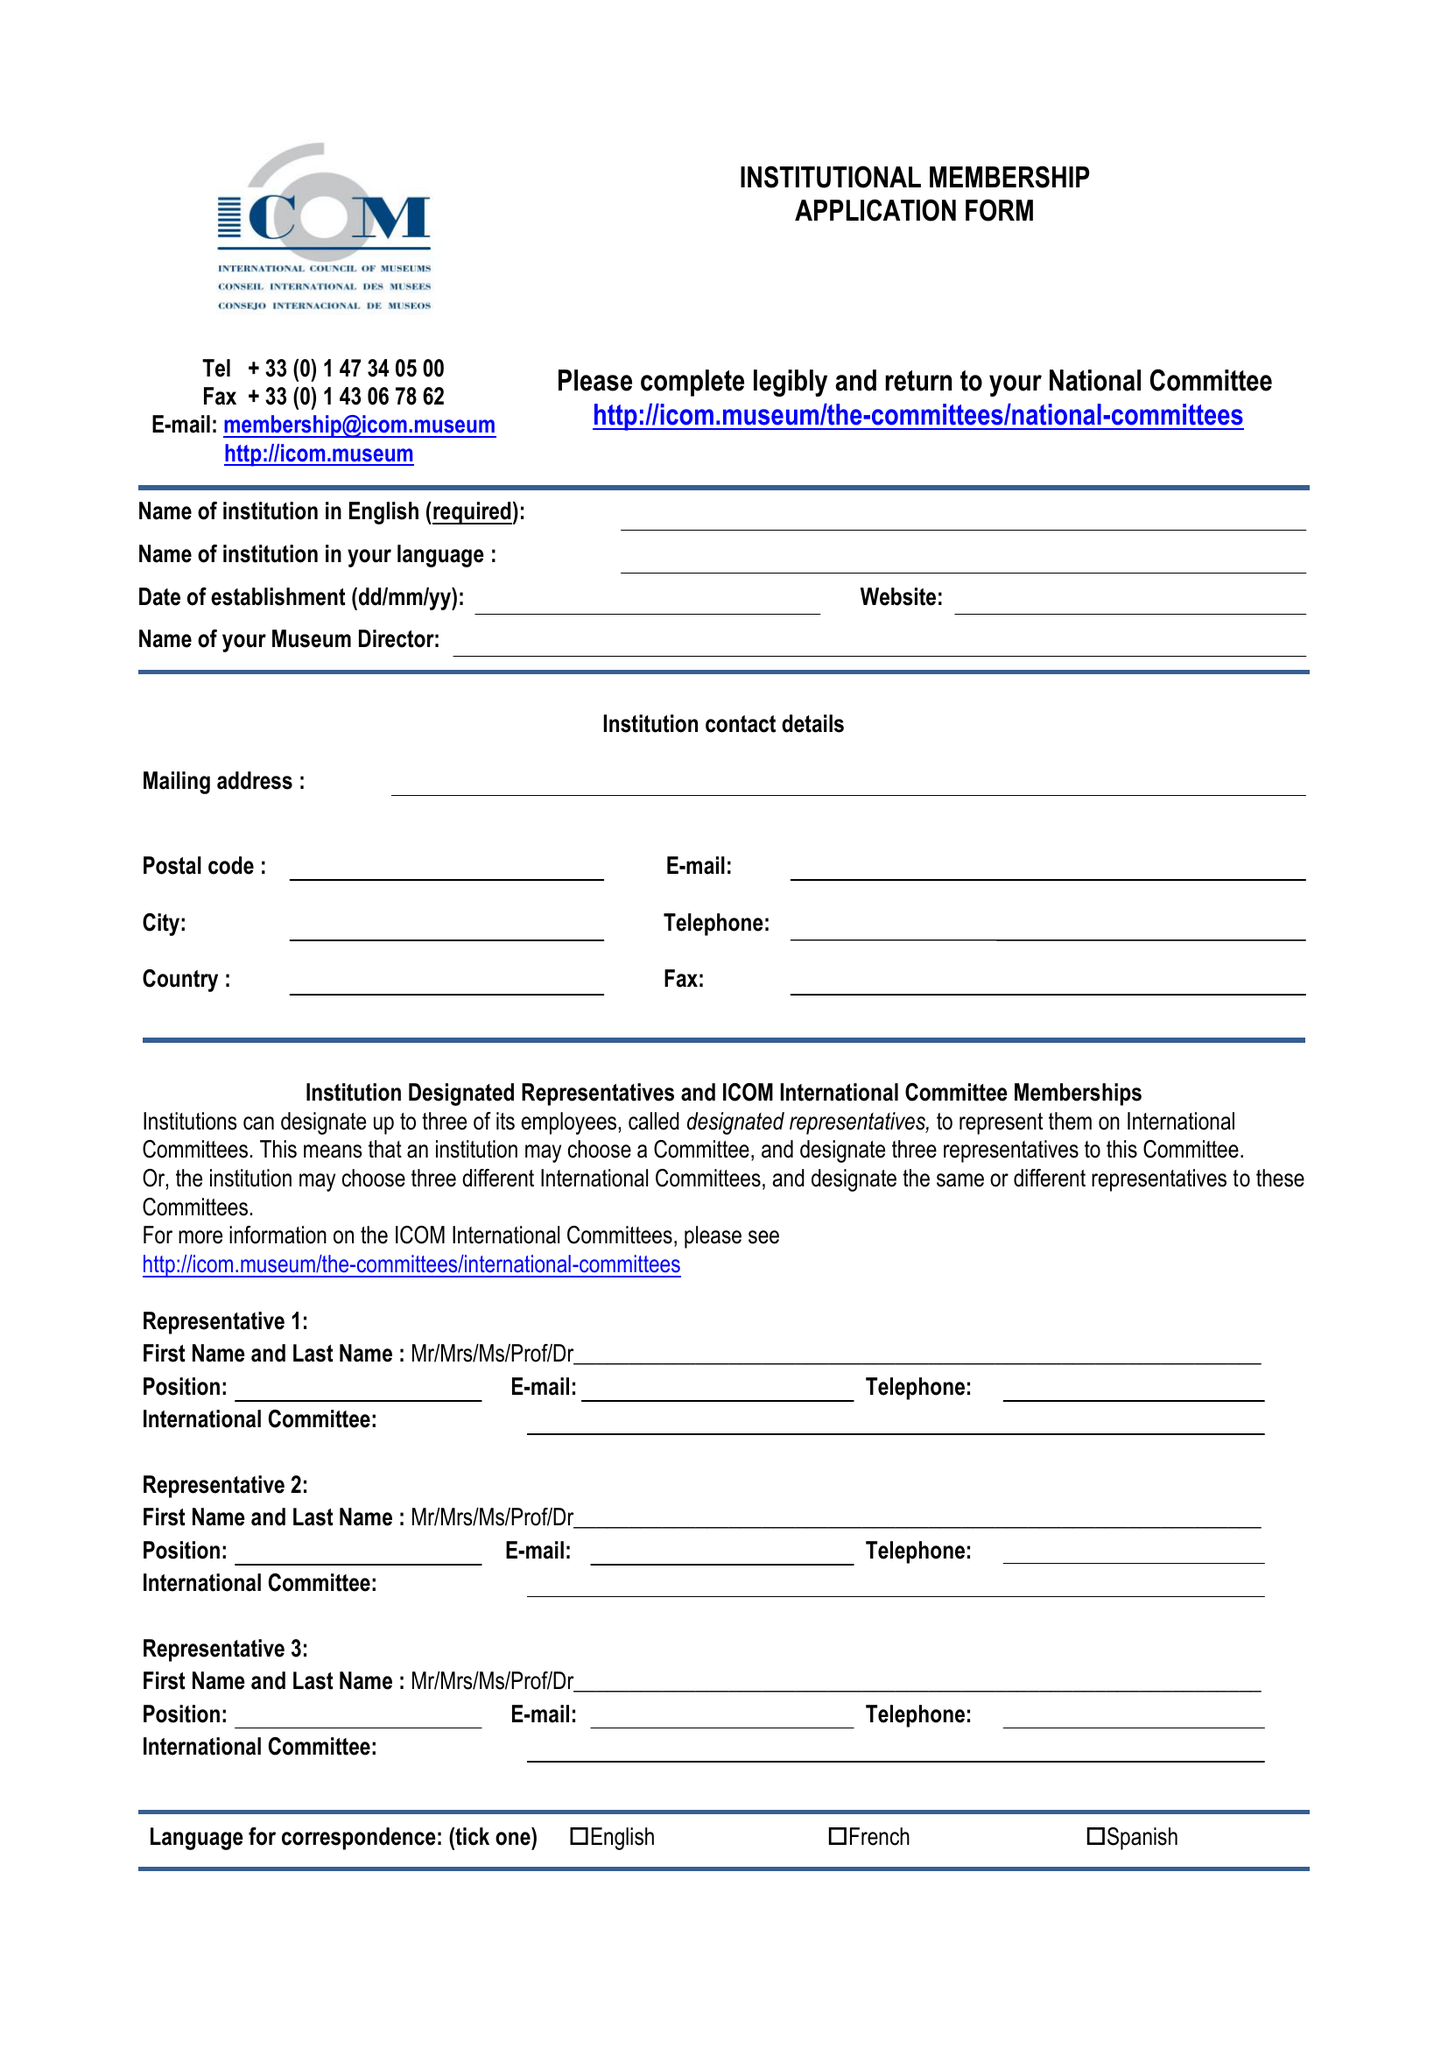What is the value for the income_annually_in_british_pounds?
Answer the question using a single word or phrase. 140064.00 